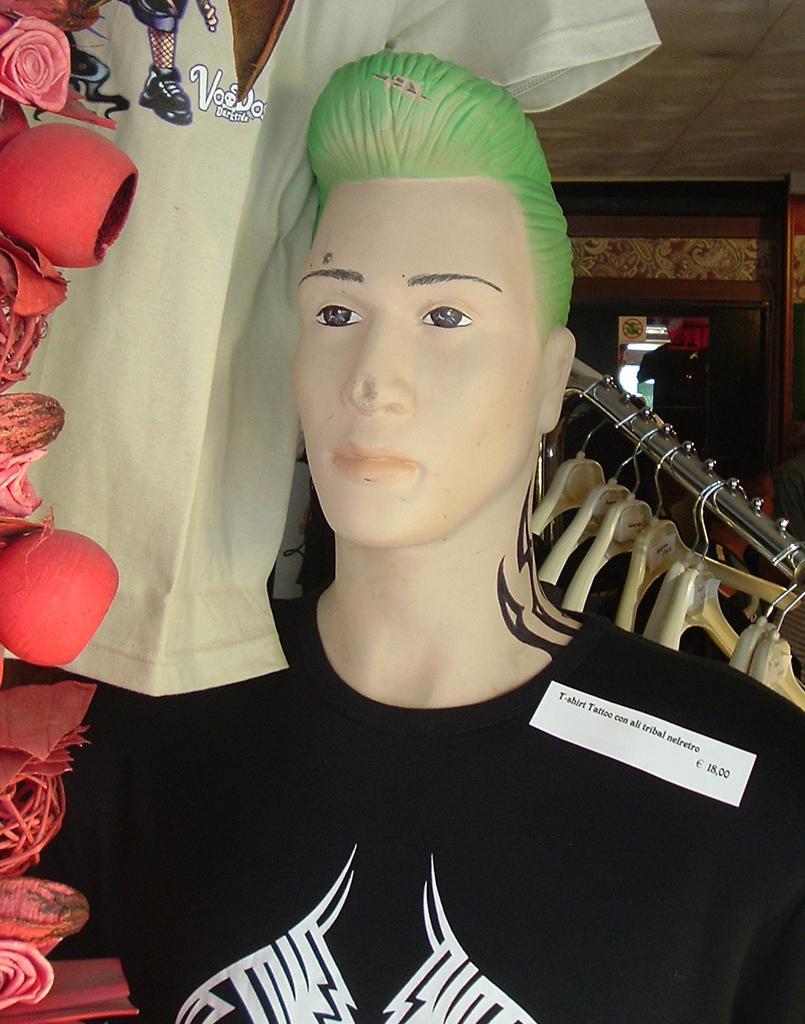Describe this image in one or two sentences. In this picture there is a dummy with black t-shirt and there is a tag on the t-shirt. At the back there is a mirror. On the left side of the image there is a t-shirt and there is a decoration. 